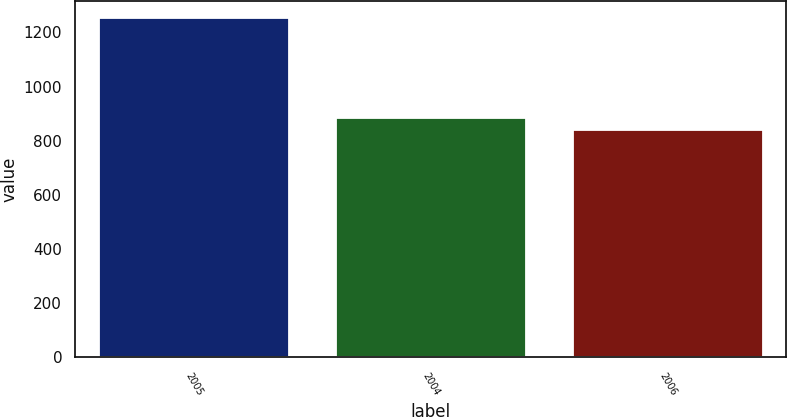<chart> <loc_0><loc_0><loc_500><loc_500><bar_chart><fcel>2005<fcel>2004<fcel>2006<nl><fcel>1252<fcel>882.1<fcel>841<nl></chart> 